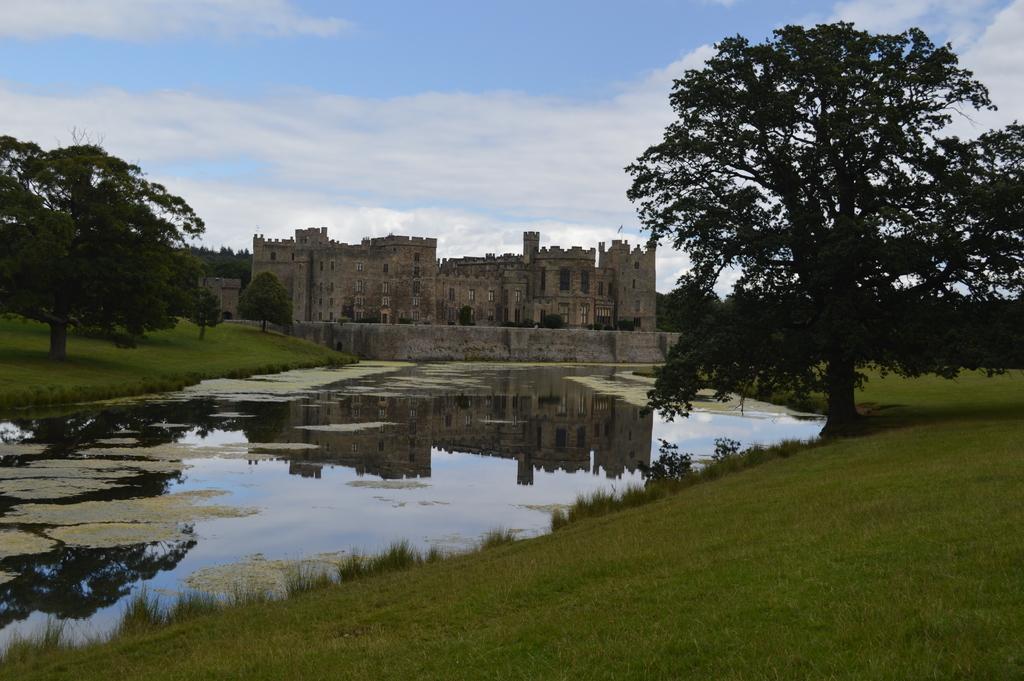Please provide a concise description of this image. In this image, we can see a water with algae. At the bottom, there is a grass. Here we can see plants and trees. Background there is a sky and fort with walls and windows. 